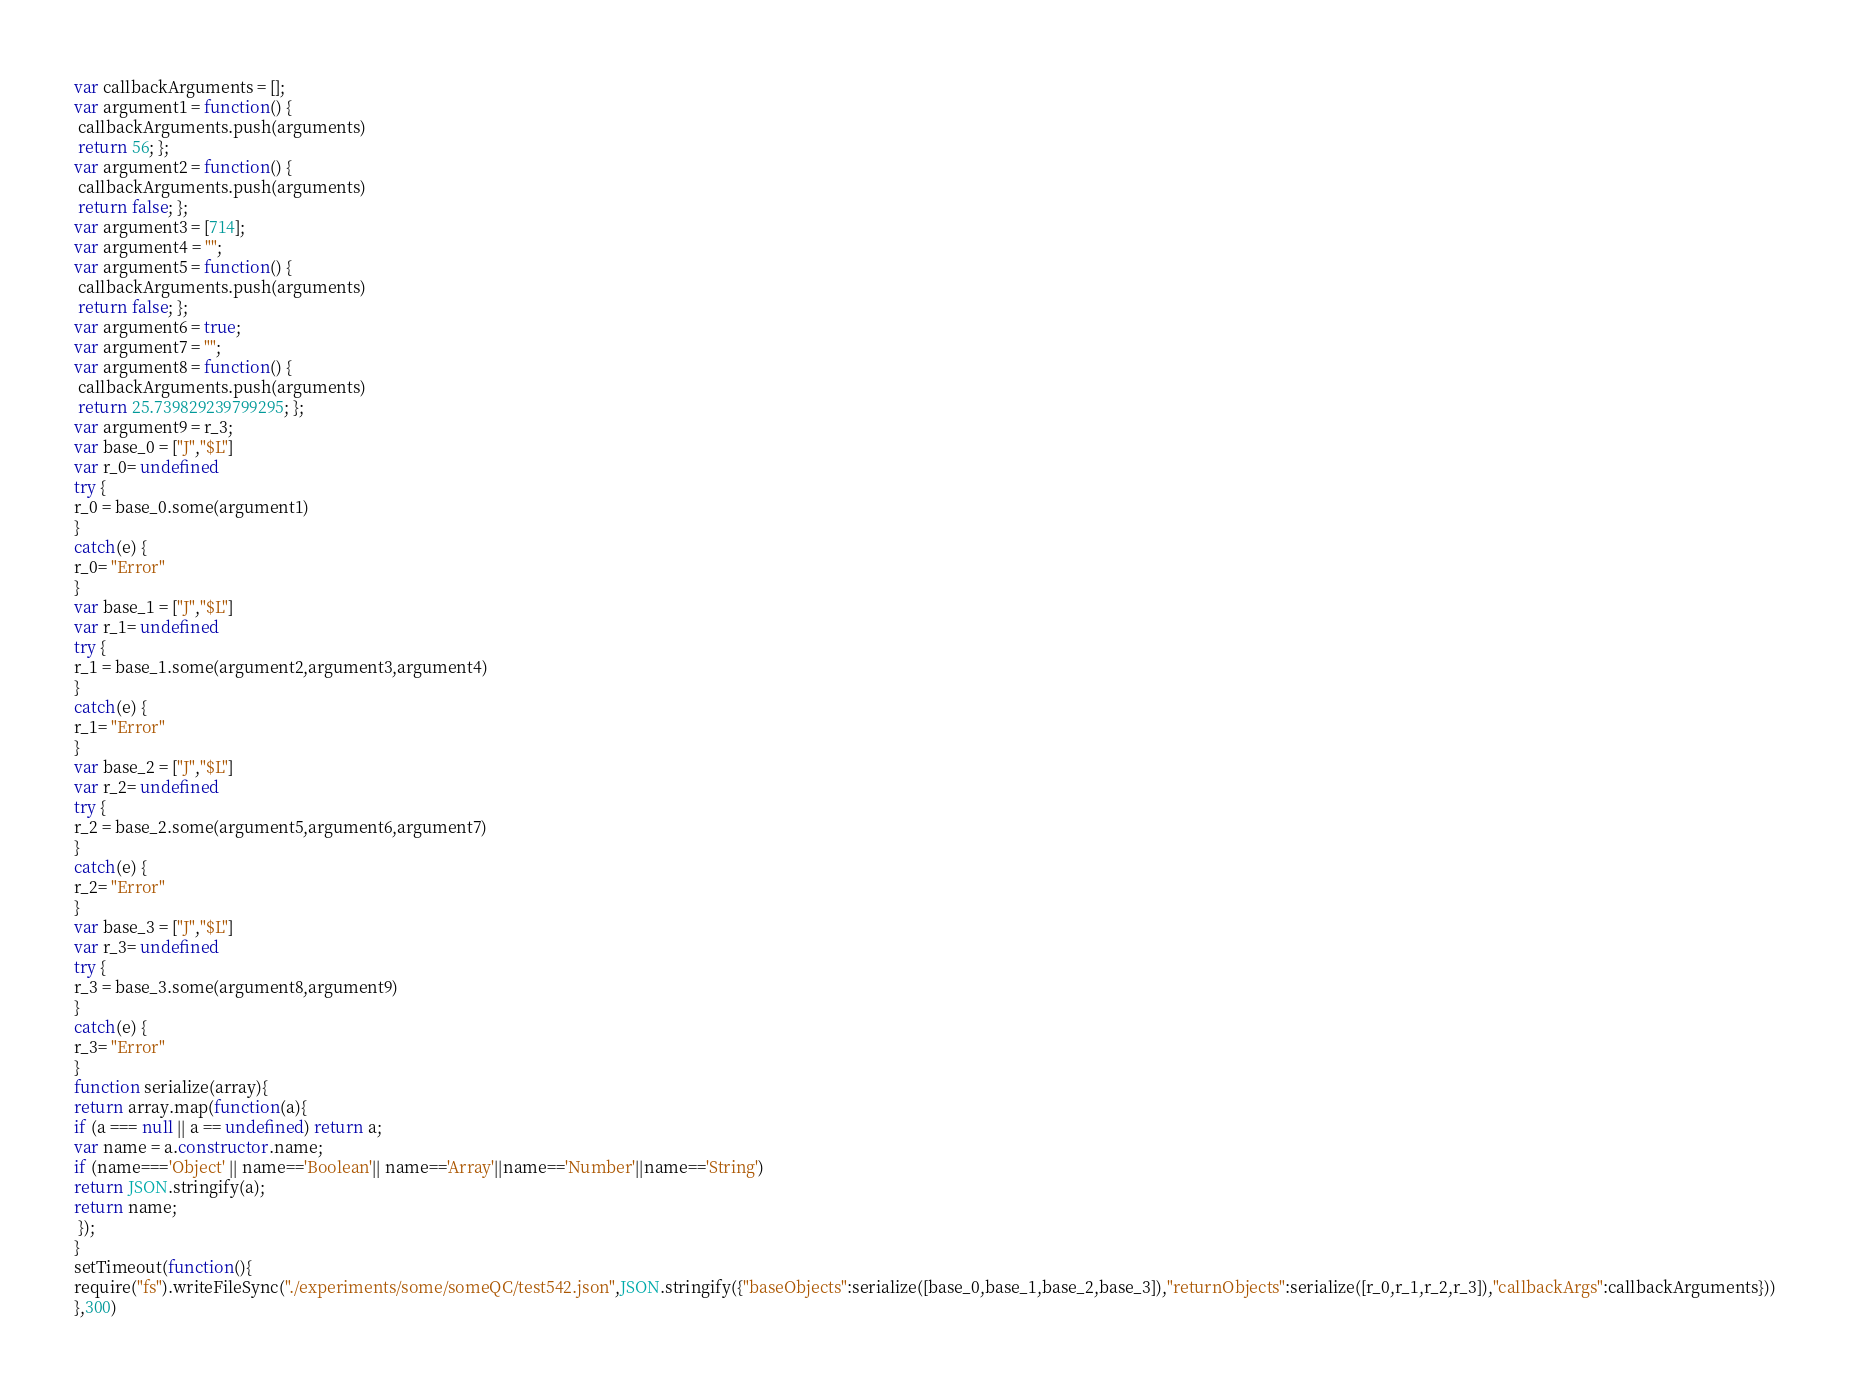<code> <loc_0><loc_0><loc_500><loc_500><_JavaScript_>





var callbackArguments = [];
var argument1 = function() {
 callbackArguments.push(arguments) 
 return 56; };
var argument2 = function() {
 callbackArguments.push(arguments) 
 return false; };
var argument3 = [714];
var argument4 = "";
var argument5 = function() {
 callbackArguments.push(arguments) 
 return false; };
var argument6 = true;
var argument7 = "";
var argument8 = function() {
 callbackArguments.push(arguments) 
 return 25.739829239799295; };
var argument9 = r_3;
var base_0 = ["J","$L"]
var r_0= undefined
try {
r_0 = base_0.some(argument1)
}
catch(e) {
r_0= "Error"
}
var base_1 = ["J","$L"]
var r_1= undefined
try {
r_1 = base_1.some(argument2,argument3,argument4)
}
catch(e) {
r_1= "Error"
}
var base_2 = ["J","$L"]
var r_2= undefined
try {
r_2 = base_2.some(argument5,argument6,argument7)
}
catch(e) {
r_2= "Error"
}
var base_3 = ["J","$L"]
var r_3= undefined
try {
r_3 = base_3.some(argument8,argument9)
}
catch(e) {
r_3= "Error"
}
function serialize(array){
return array.map(function(a){
if (a === null || a == undefined) return a;
var name = a.constructor.name;
if (name==='Object' || name=='Boolean'|| name=='Array'||name=='Number'||name=='String')
return JSON.stringify(a);
return name;
 });
}
setTimeout(function(){
require("fs").writeFileSync("./experiments/some/someQC/test542.json",JSON.stringify({"baseObjects":serialize([base_0,base_1,base_2,base_3]),"returnObjects":serialize([r_0,r_1,r_2,r_3]),"callbackArgs":callbackArguments}))
},300)</code> 